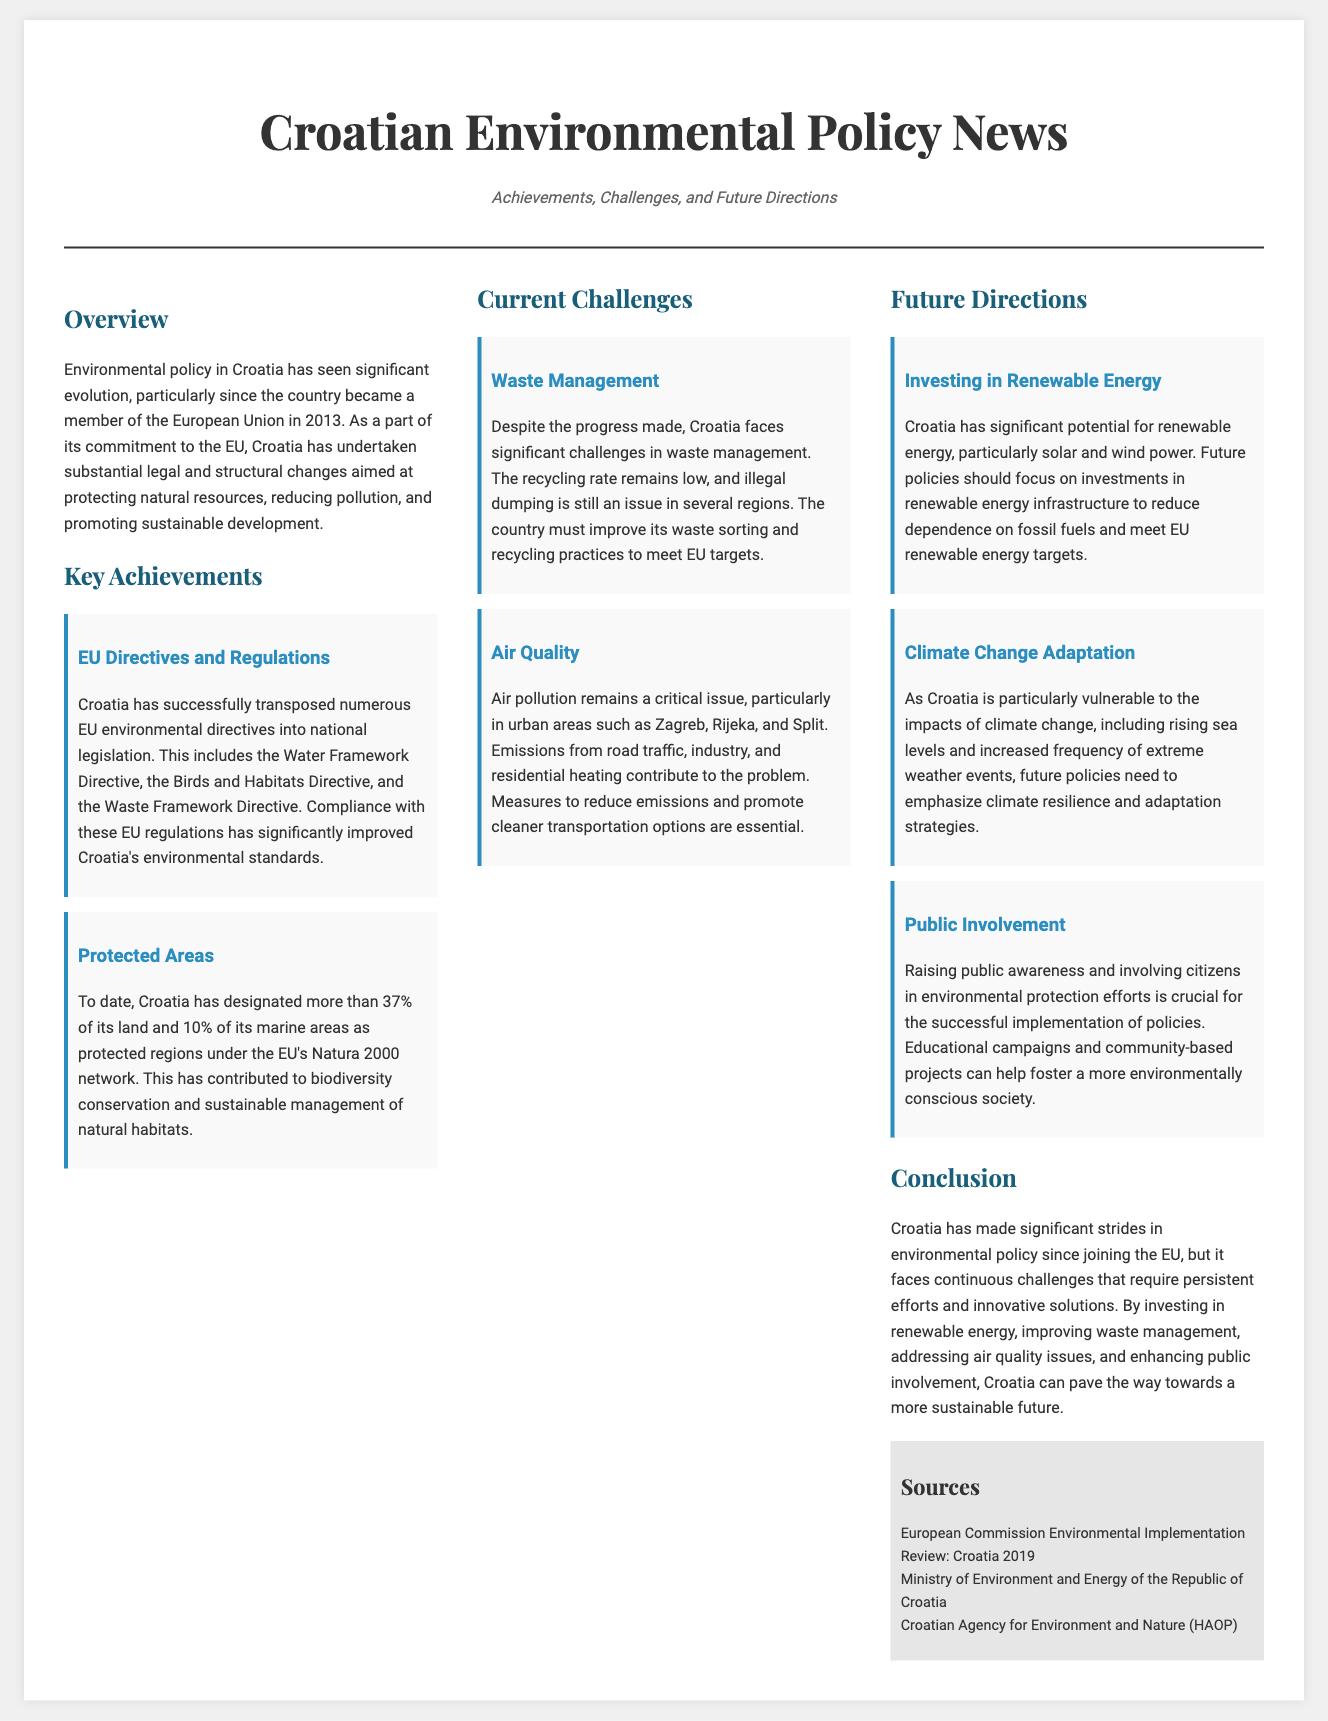What year did Croatia join the EU? The document states that Croatia became a member of the European Union in 2013.
Answer: 2013 What percentage of Croatia's land is protected? The document mentions that Croatia has designated more than 37% of its land as protected regions.
Answer: More than 37% Which directive related to water has Croatia transposed? The document lists the Water Framework Directive as one of the EU directives transposed into national legislation.
Answer: Water Framework Directive What is a major challenge for Croatia mentioned in the document? The document highlights waste management and air quality as significant challenges faced by Croatia.
Answer: Waste management What should future policies in Croatia focus on regarding energy? The document suggests that future policies should focus on investments in renewable energy infrastructure.
Answer: Investments in renewable energy infrastructure What type of public action is emphasized for environmental protection? The document states the importance of raising public awareness and involving citizens in efforts for environmental protection.
Answer: Raising public awareness How much of Croatia's marine areas are protected? The document states that 10% of Croatia's marine areas are designated as protected.
Answer: 10% What is the projected impact of climate change mentioned in the article? The document notes rising sea levels and increased frequency of extreme weather events as impacts of climate change on Croatia.
Answer: Rising sea levels Which city is specifically mentioned as having air quality issues? The document mentions urban areas such as Zagreb, Rijeka, and Split regarding air quality issues.
Answer: Zagreb 